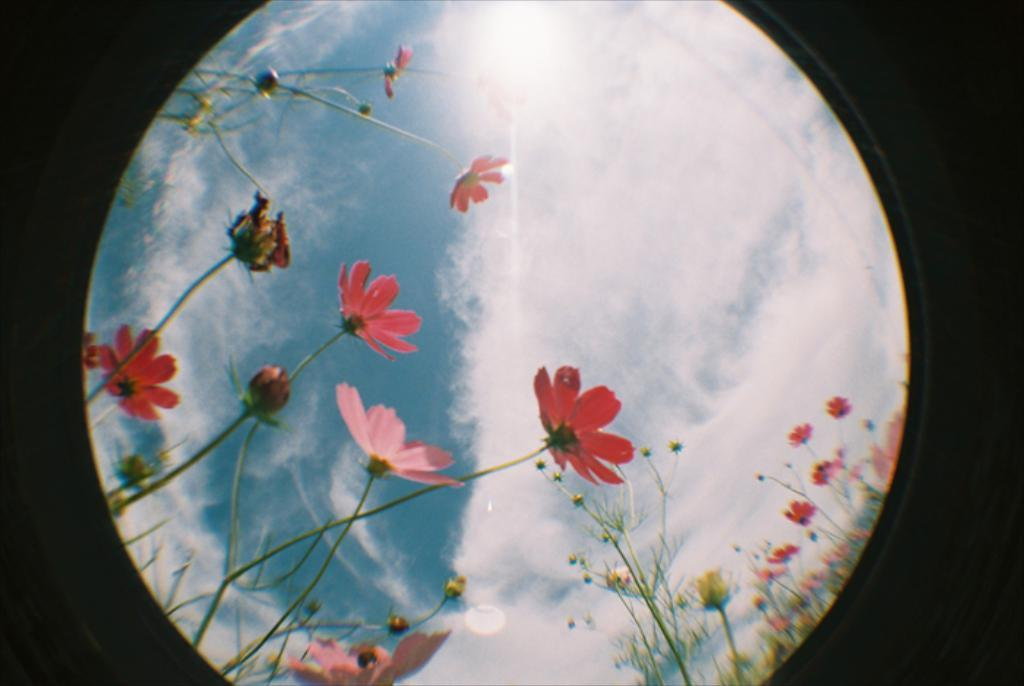What type of living organisms can be seen in the image? Flowers and plants are visible in the image. What can be seen in the sky in the image? Clouds are visible in the image. What is the color of the background in the image? The background of the image is dark. What type of lock can be seen securing the crow in the image? There is no lock or crow present in the image. How does the transport system operate in the image? There is no transport system present in the image. 